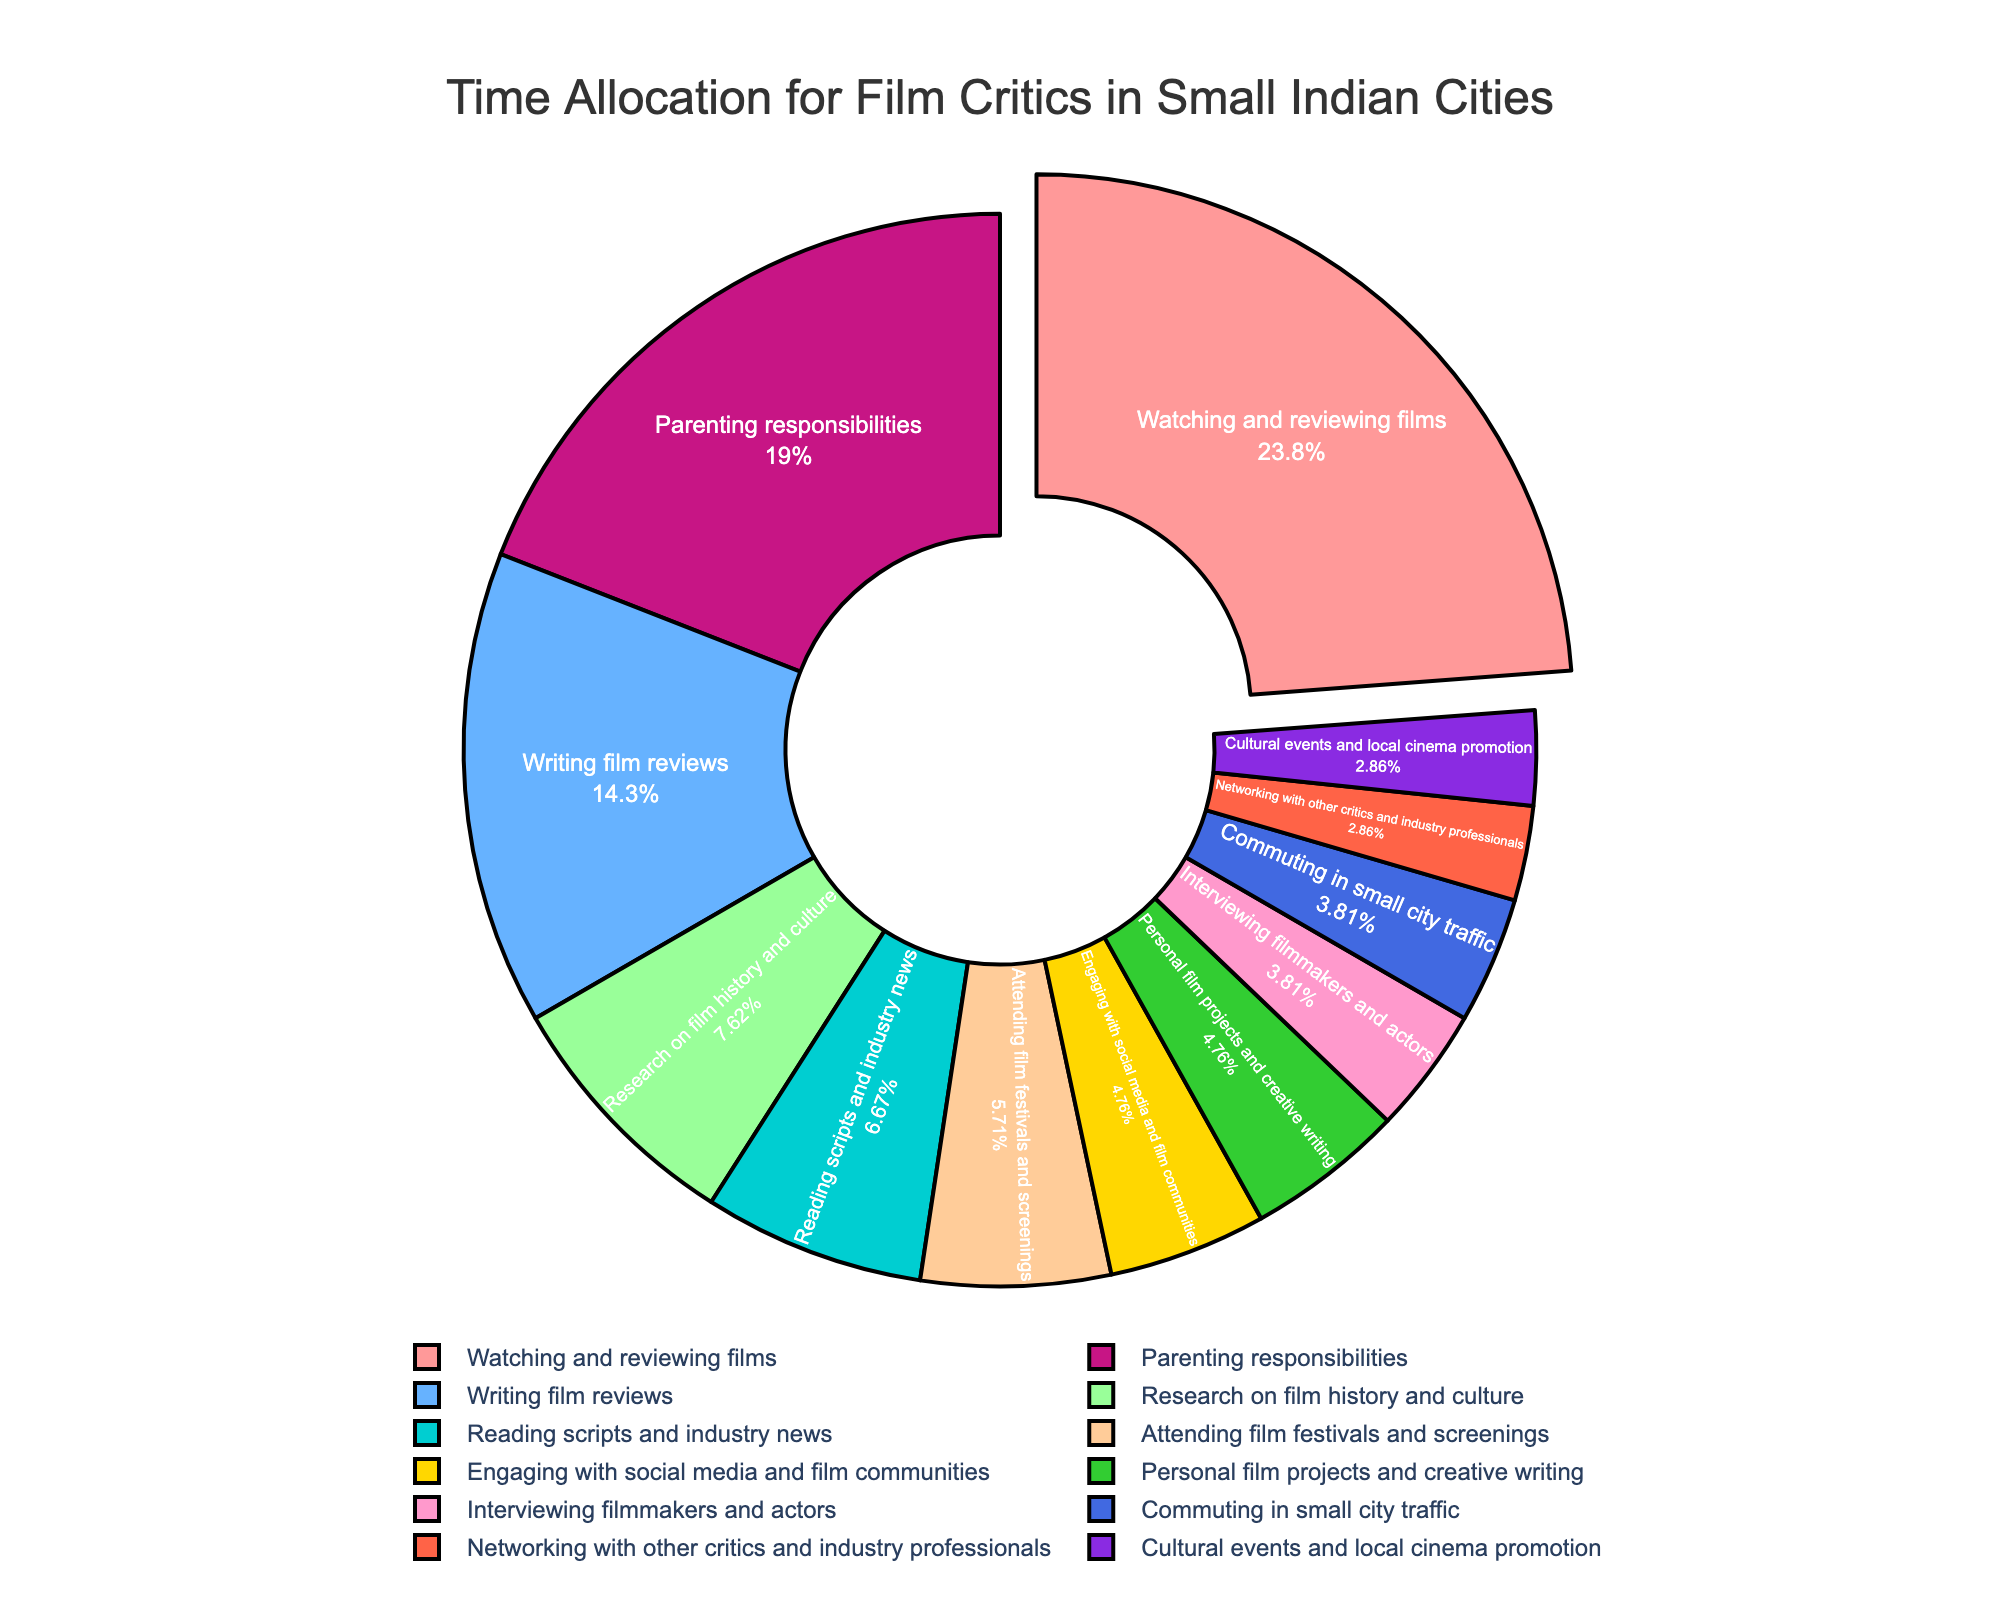What activity takes up the most time for film critics in small Indian cities? From the pie chart, the largest segment represents "Watching and reviewing films" which takes up the most time.
Answer: Watching and reviewing films What percentage of time is spent on parenting responsibilities? The pie chart shows the percentage of each activity. For "Parenting responsibilities," the percentage shown is 20 hours out of the total, which translates to approximately 20%.
Answer: 20% How does the time spent on writing film reviews compare to time spent on reading scripts and industry news? The pie chart shows that 15 hours are spent on writing film reviews, while 7 hours are spent on reading scripts and industry news. 15 is greater than 7.
Answer: More time is spent on writing film reviews What is the combined time allocated to engaging with social media and networking with other critics? From the chart, 5 hours are spent on engaging with social media, and 3 hours on networking with other critics. So, 5 + 3 = 8 hours.
Answer: 8 hours Which activities take up an equal amount of time in the week's schedule? The pie chart segments need to be checked for equal sizes. "Commuting in small city traffic" and "Interviewing filmmakers and actors" both are 4 hours each, also "Networking with other critics and industry professionals" and "Cultural events and local cinema promotion" both take 3 hours.
Answer: Commuting in small city traffic, Interviewing filmmakers and actors; Networking with other critics and industry professionals, Cultural events and local cinema promotion What is the smallest activity by time allocation among all the listed activities? The smallest segment in the pie chart represents "Networking with other critics and industry professionals" and "Cultural events and local cinema promotion," both at 3 hours per week.
Answer: Networking with other critics and industry professionals, Cultural events and local cinema promotion If a film critic spends an equal number of hours on research on film history and creative writing, how many hours would that be in total each week? The pie chart shows that 8 hours are spent on research on film history and culture, and 5 hours on personal film projects and creative writing, so 8 + 5 = 13 hours in total.
Answer: 13 hours What is the difference between the time spent on parenting responsibilities and attending film festivals? From the pie chart, 20 hours are spent on parenting responsibilities, and 6 hours on attending film festivals. The difference is 20 - 6 = 14 hours.
Answer: 14 hours What activities are associated with professional networking, and what is their cumulative time allocation? From the pie chart, "Attending film festivals and screenings" (6 hours) and "Networking with other critics and industry professionals" (3 hours) are associated with professional networking. The cumulative time is 6 + 3 = 9 hours.
Answer: 9 hours 